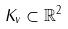<formula> <loc_0><loc_0><loc_500><loc_500>K _ { v } \subset \mathbb { R } ^ { 2 }</formula> 